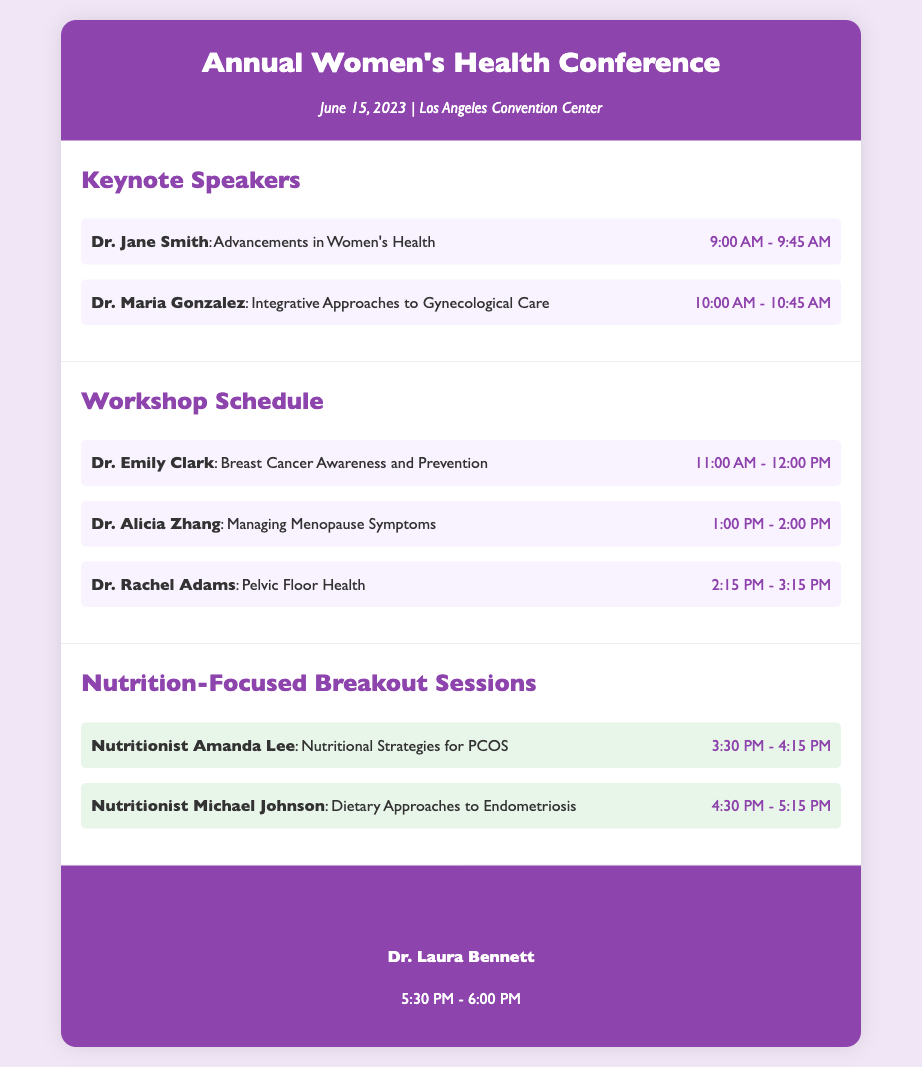What is the date of the conference? The date of the conference is mentioned in the header section of the document.
Answer: June 15, 2023 Who is the keynote speaker discussing PCOS nutritional strategies? This information can be found in the Nutrition-Focused Breakout Sessions section, where the specific speakers are listed.
Answer: Nutritionist Amanda Lee What time does the workshop on Managing Menopause Symptoms start? The start time for this workshop is provided in the Workshop Schedule section.
Answer: 1:00 PM How long is the session on Dietary Approaches to Endometriosis? This question concerns the duration of the breakout session mentioned in the document.
Answer: 45 minutes Which speaker is giving the closing remarks? The closing remarks speaker is detailed in the footer section of the document.
Answer: Dr. Laura Bennett What are the two topics covered by the nutrition-focused breakout sessions? The topics can be found by looking at the titles listed under the Nutrition-Focused Breakout Sessions section.
Answer: Nutritional Strategies for PCOS and Dietary Approaches to Endometriosis Who is speaking on Pelvic Floor Health? This information can be found in the Workshop Schedule section where all workshop speakers are mentioned.
Answer: Dr. Rachel Adams At what time do the keynote speeches end? The end time can be calculated by looking at the timings of the keynote speakers.
Answer: 10:45 AM 